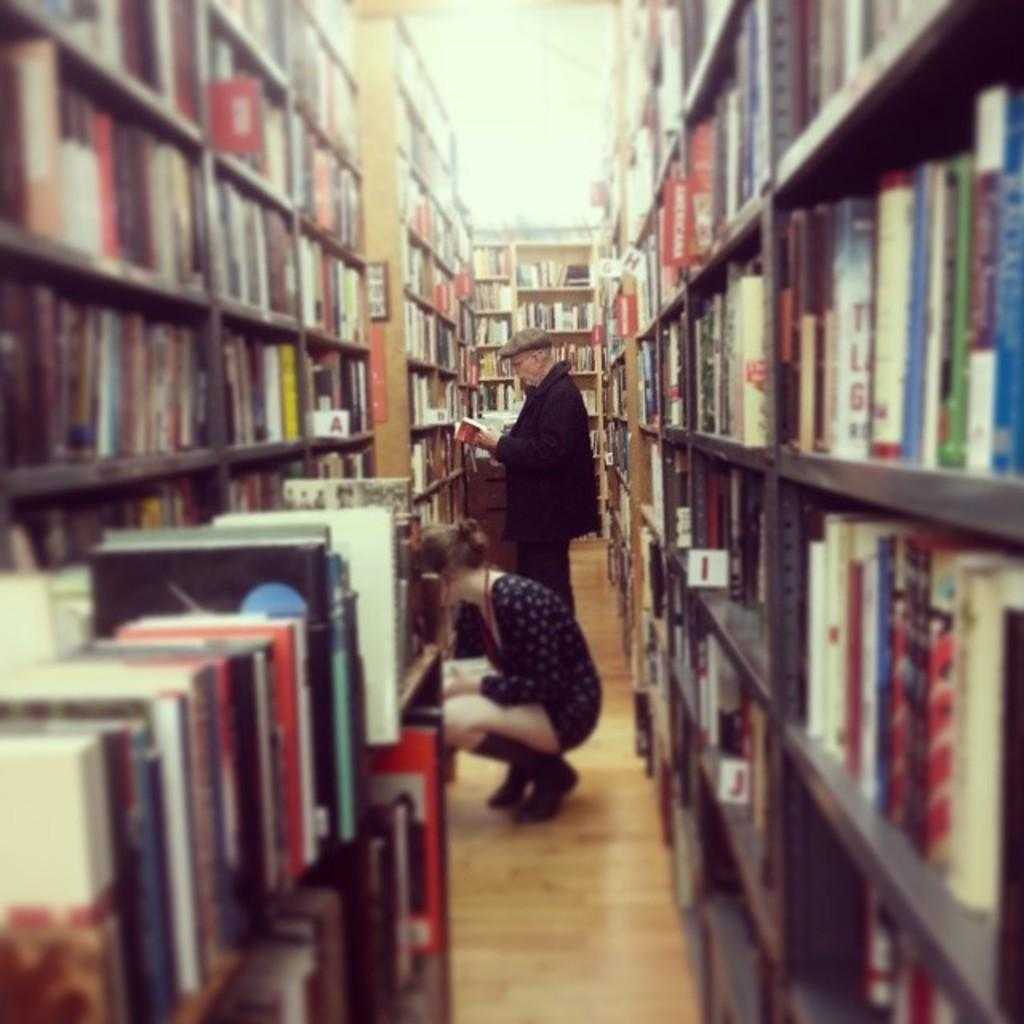Provide a one-sentence caption for the provided image. Library shelves are arranged and labeled with an alphabet system, and the letters A, B, I and J are visible. 